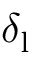<formula> <loc_0><loc_0><loc_500><loc_500>\delta _ { l }</formula> 